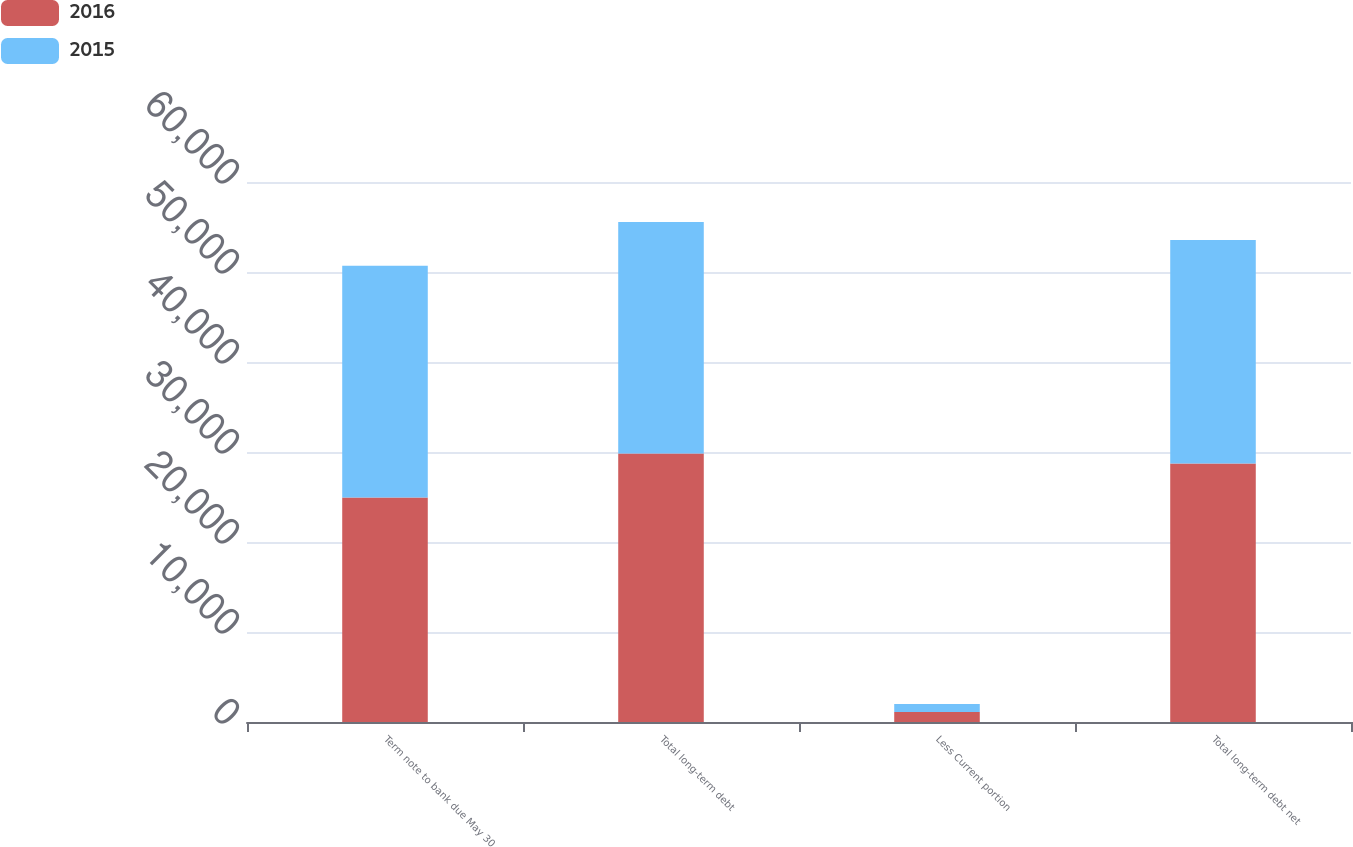Convert chart. <chart><loc_0><loc_0><loc_500><loc_500><stacked_bar_chart><ecel><fcel>Term note to bank due May 30<fcel>Total long-term debt<fcel>Less Current portion<fcel>Total long-term debt net<nl><fcel>2016<fcel>24950<fcel>29824<fcel>1113<fcel>28711<nl><fcel>2015<fcel>25742<fcel>25742<fcel>886<fcel>24856<nl></chart> 